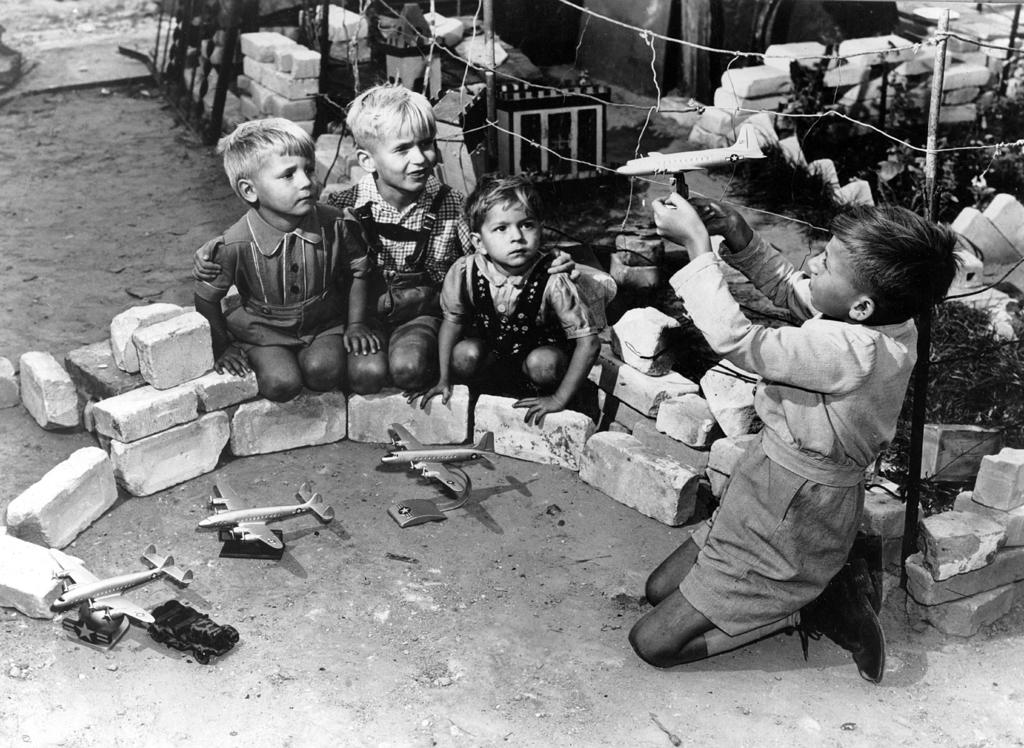What are the people in the image doing? The people in the image are sitting. What is one person holding in the image? One person is holding something. What type of vehicles can be seen in the image? There are aeroplanes in the image. What type of natural elements are present in the image? There are stones in the image. What is on the ground in the image? There are objects on the ground. What is the color scheme of the image? The image is in black and white. What type of thought can be seen in the image? There are no thoughts visible in the image, as thoughts are not something that can be seen. Is there a cap visible on any of the people in the image? There is no cap visible on any of the people in the image. 